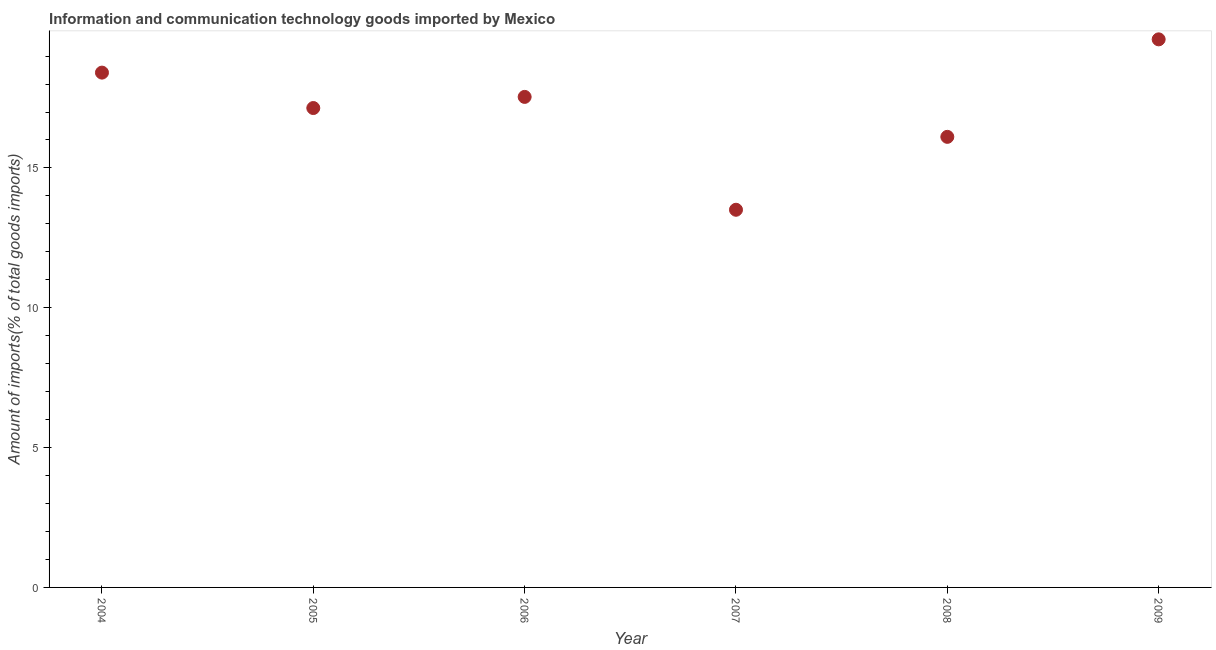What is the amount of ict goods imports in 2008?
Offer a very short reply. 16.11. Across all years, what is the maximum amount of ict goods imports?
Keep it short and to the point. 19.6. Across all years, what is the minimum amount of ict goods imports?
Offer a terse response. 13.51. In which year was the amount of ict goods imports maximum?
Offer a very short reply. 2009. In which year was the amount of ict goods imports minimum?
Provide a succinct answer. 2007. What is the sum of the amount of ict goods imports?
Your answer should be compact. 102.31. What is the difference between the amount of ict goods imports in 2006 and 2007?
Offer a terse response. 4.04. What is the average amount of ict goods imports per year?
Provide a short and direct response. 17.05. What is the median amount of ict goods imports?
Your answer should be very brief. 17.34. What is the ratio of the amount of ict goods imports in 2007 to that in 2009?
Your answer should be very brief. 0.69. What is the difference between the highest and the second highest amount of ict goods imports?
Your response must be concise. 1.19. What is the difference between the highest and the lowest amount of ict goods imports?
Offer a terse response. 6.09. How many dotlines are there?
Keep it short and to the point. 1. How many years are there in the graph?
Provide a succinct answer. 6. What is the difference between two consecutive major ticks on the Y-axis?
Provide a short and direct response. 5. Are the values on the major ticks of Y-axis written in scientific E-notation?
Your answer should be compact. No. Does the graph contain any zero values?
Your answer should be compact. No. What is the title of the graph?
Offer a terse response. Information and communication technology goods imported by Mexico. What is the label or title of the Y-axis?
Ensure brevity in your answer.  Amount of imports(% of total goods imports). What is the Amount of imports(% of total goods imports) in 2004?
Provide a short and direct response. 18.41. What is the Amount of imports(% of total goods imports) in 2005?
Make the answer very short. 17.14. What is the Amount of imports(% of total goods imports) in 2006?
Provide a succinct answer. 17.54. What is the Amount of imports(% of total goods imports) in 2007?
Provide a short and direct response. 13.51. What is the Amount of imports(% of total goods imports) in 2008?
Make the answer very short. 16.11. What is the Amount of imports(% of total goods imports) in 2009?
Ensure brevity in your answer.  19.6. What is the difference between the Amount of imports(% of total goods imports) in 2004 and 2005?
Your response must be concise. 1.27. What is the difference between the Amount of imports(% of total goods imports) in 2004 and 2006?
Ensure brevity in your answer.  0.87. What is the difference between the Amount of imports(% of total goods imports) in 2004 and 2007?
Provide a short and direct response. 4.9. What is the difference between the Amount of imports(% of total goods imports) in 2004 and 2008?
Your answer should be compact. 2.3. What is the difference between the Amount of imports(% of total goods imports) in 2004 and 2009?
Keep it short and to the point. -1.19. What is the difference between the Amount of imports(% of total goods imports) in 2005 and 2006?
Your answer should be very brief. -0.4. What is the difference between the Amount of imports(% of total goods imports) in 2005 and 2007?
Provide a succinct answer. 3.64. What is the difference between the Amount of imports(% of total goods imports) in 2005 and 2008?
Your answer should be compact. 1.03. What is the difference between the Amount of imports(% of total goods imports) in 2005 and 2009?
Your response must be concise. -2.46. What is the difference between the Amount of imports(% of total goods imports) in 2006 and 2007?
Give a very brief answer. 4.04. What is the difference between the Amount of imports(% of total goods imports) in 2006 and 2008?
Keep it short and to the point. 1.43. What is the difference between the Amount of imports(% of total goods imports) in 2006 and 2009?
Offer a terse response. -2.06. What is the difference between the Amount of imports(% of total goods imports) in 2007 and 2008?
Provide a succinct answer. -2.61. What is the difference between the Amount of imports(% of total goods imports) in 2007 and 2009?
Provide a short and direct response. -6.09. What is the difference between the Amount of imports(% of total goods imports) in 2008 and 2009?
Ensure brevity in your answer.  -3.49. What is the ratio of the Amount of imports(% of total goods imports) in 2004 to that in 2005?
Make the answer very short. 1.07. What is the ratio of the Amount of imports(% of total goods imports) in 2004 to that in 2007?
Your response must be concise. 1.36. What is the ratio of the Amount of imports(% of total goods imports) in 2004 to that in 2008?
Provide a succinct answer. 1.14. What is the ratio of the Amount of imports(% of total goods imports) in 2004 to that in 2009?
Offer a very short reply. 0.94. What is the ratio of the Amount of imports(% of total goods imports) in 2005 to that in 2007?
Provide a succinct answer. 1.27. What is the ratio of the Amount of imports(% of total goods imports) in 2005 to that in 2008?
Ensure brevity in your answer.  1.06. What is the ratio of the Amount of imports(% of total goods imports) in 2006 to that in 2007?
Offer a very short reply. 1.3. What is the ratio of the Amount of imports(% of total goods imports) in 2006 to that in 2008?
Your response must be concise. 1.09. What is the ratio of the Amount of imports(% of total goods imports) in 2006 to that in 2009?
Make the answer very short. 0.9. What is the ratio of the Amount of imports(% of total goods imports) in 2007 to that in 2008?
Your answer should be very brief. 0.84. What is the ratio of the Amount of imports(% of total goods imports) in 2007 to that in 2009?
Offer a terse response. 0.69. What is the ratio of the Amount of imports(% of total goods imports) in 2008 to that in 2009?
Offer a terse response. 0.82. 